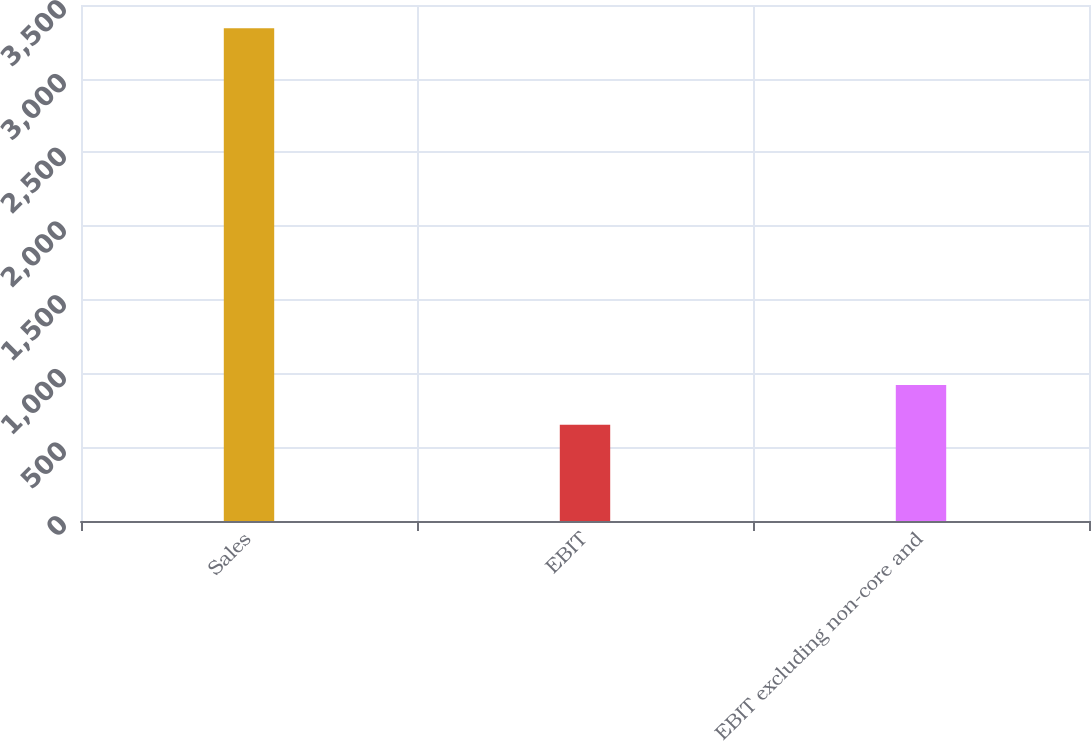Convert chart to OTSL. <chart><loc_0><loc_0><loc_500><loc_500><bar_chart><fcel>Sales<fcel>EBIT<fcel>EBIT excluding non-core and<nl><fcel>3343<fcel>653<fcel>922<nl></chart> 